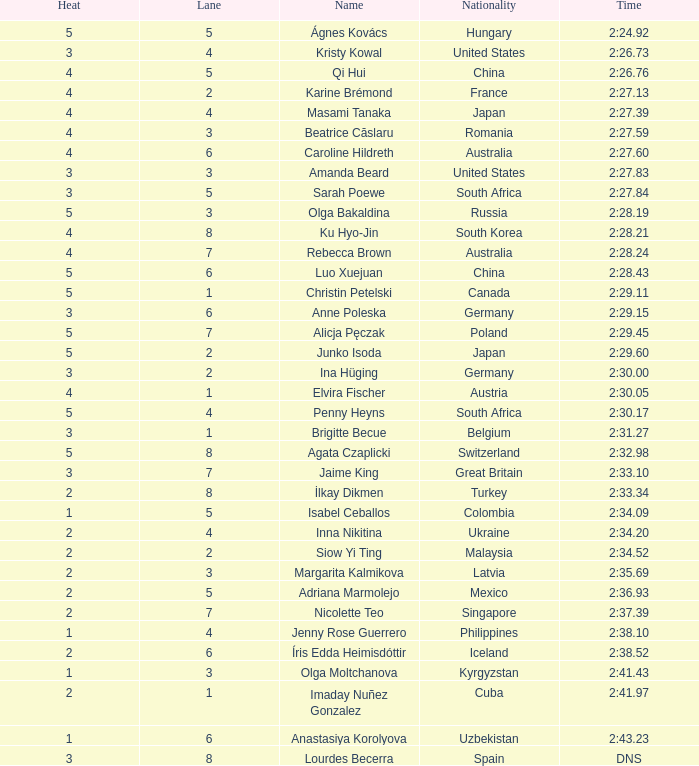What path did inna nikitina follow? 4.0. 